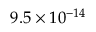Convert formula to latex. <formula><loc_0><loc_0><loc_500><loc_500>9 . 5 \times 1 0 ^ { - 1 4 }</formula> 